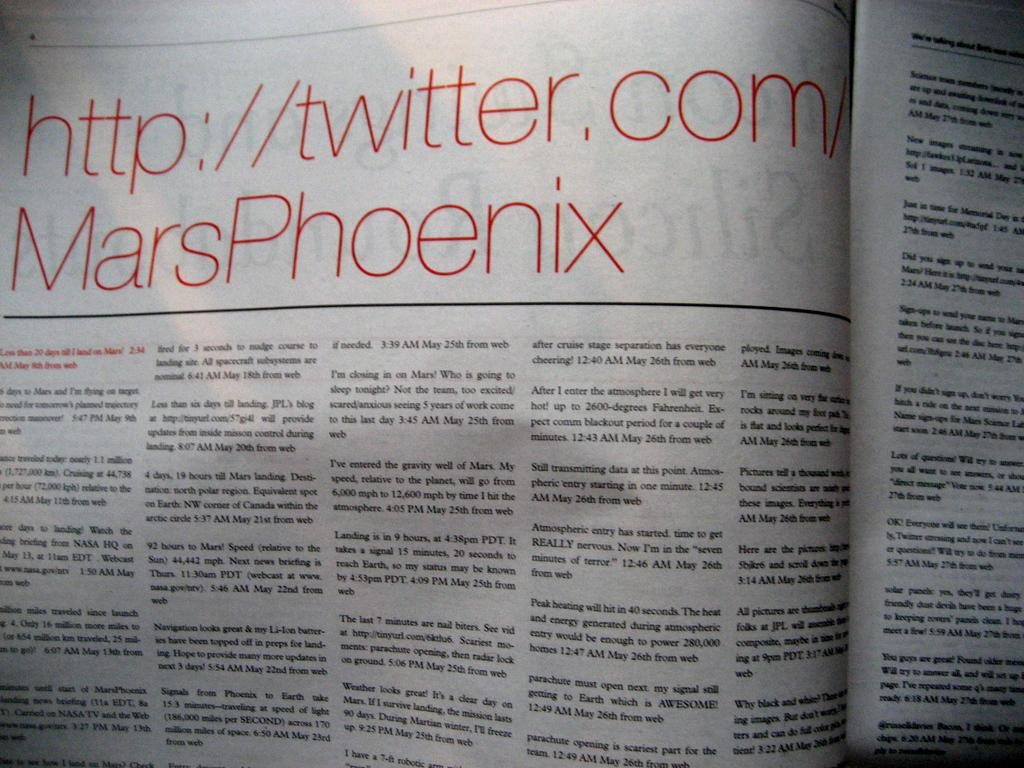Provide a one-sentence caption for the provided image. The twitter account was published in the newspaper. 